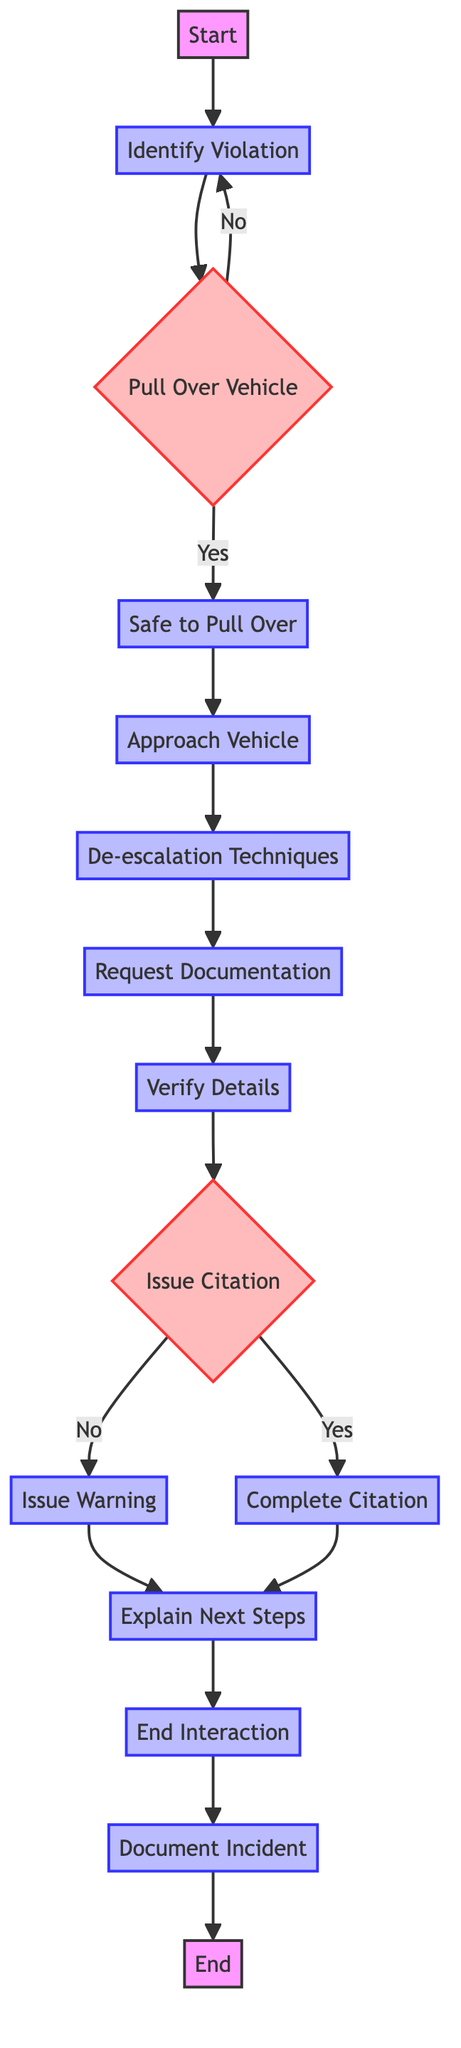What is the starting point of the process? The starting point is labeled "Start" in the flowchart and is the first node.
Answer: Start How many processes are there in the handling process? Each node that is classified as "Process" is counted. There are 8 "Process" nodes in the flowchart: Identify Violation, Safe to Pull Over, Approach Vehicle, De-escalation Techniques, Request Documentation, Verify Details, Issue Warning, Complete Citation, Explain Next Steps, End Interaction, and Document Incident.
Answer: 10 What decision needs to be made after verifying details? The decision made after verifying details is whether to "Issue Citation" or not. This is represented by the decision node labeled "Issue Citation."
Answer: Issue Citation If the vehicle cannot be pulled over, where does the flow return to? If the vehicle cannot be pulled over, the flow returns to the node "Identify Violation," allowing the officer to reassess the situation.
Answer: Identify Violation What happens after a citation is issued? After a citation is issued, the next step is completing the citation paperwork, which is represented by the node "Complete Citation."
Answer: Complete Citation What does the officer do if a citation is not issued? If a citation is not issued, the officer will proceed to "Issue Warning." This process is just for issuing a warning instead of a citation.
Answer: Issue Warning What is the last step of the process? The last step is labeled "End" in the flowchart, marking the conclusion of the traffic violation handling process.
Answer: End What defines the branching decision in the flowchart? The branching decision is defined by the node labeled "Pull Over Vehicle," which determines the flow based on whether it is safe or not to pull over the vehicle.
Answer: Pull Over Vehicle What does the officer do after explaining the next steps? After explaining the next steps to the driver, the officer proceeds to "End Interaction," indicating that the traffic stop is concluding.
Answer: End Interaction 